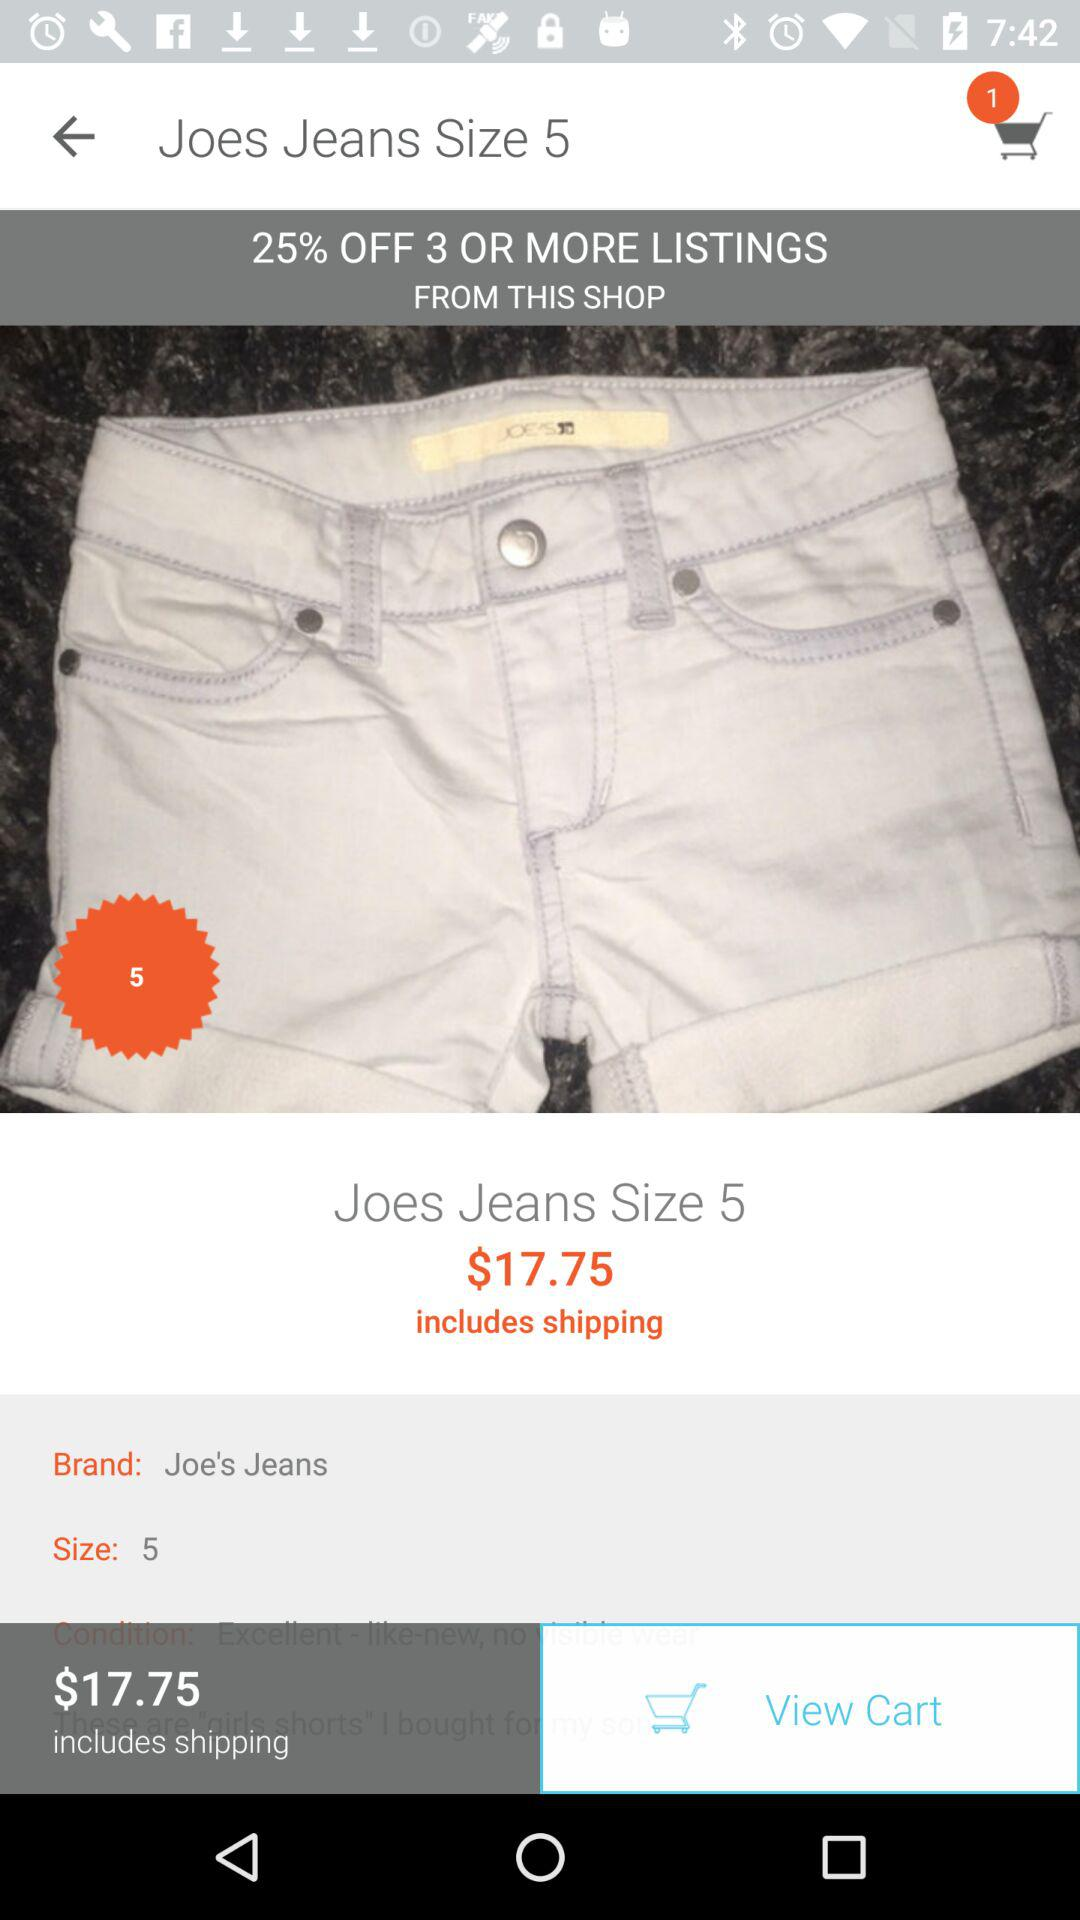What's the cost of Joe's Jeans, including shipping charges? The cost of Joe's Jeans, including shipping charges is $17.75. 